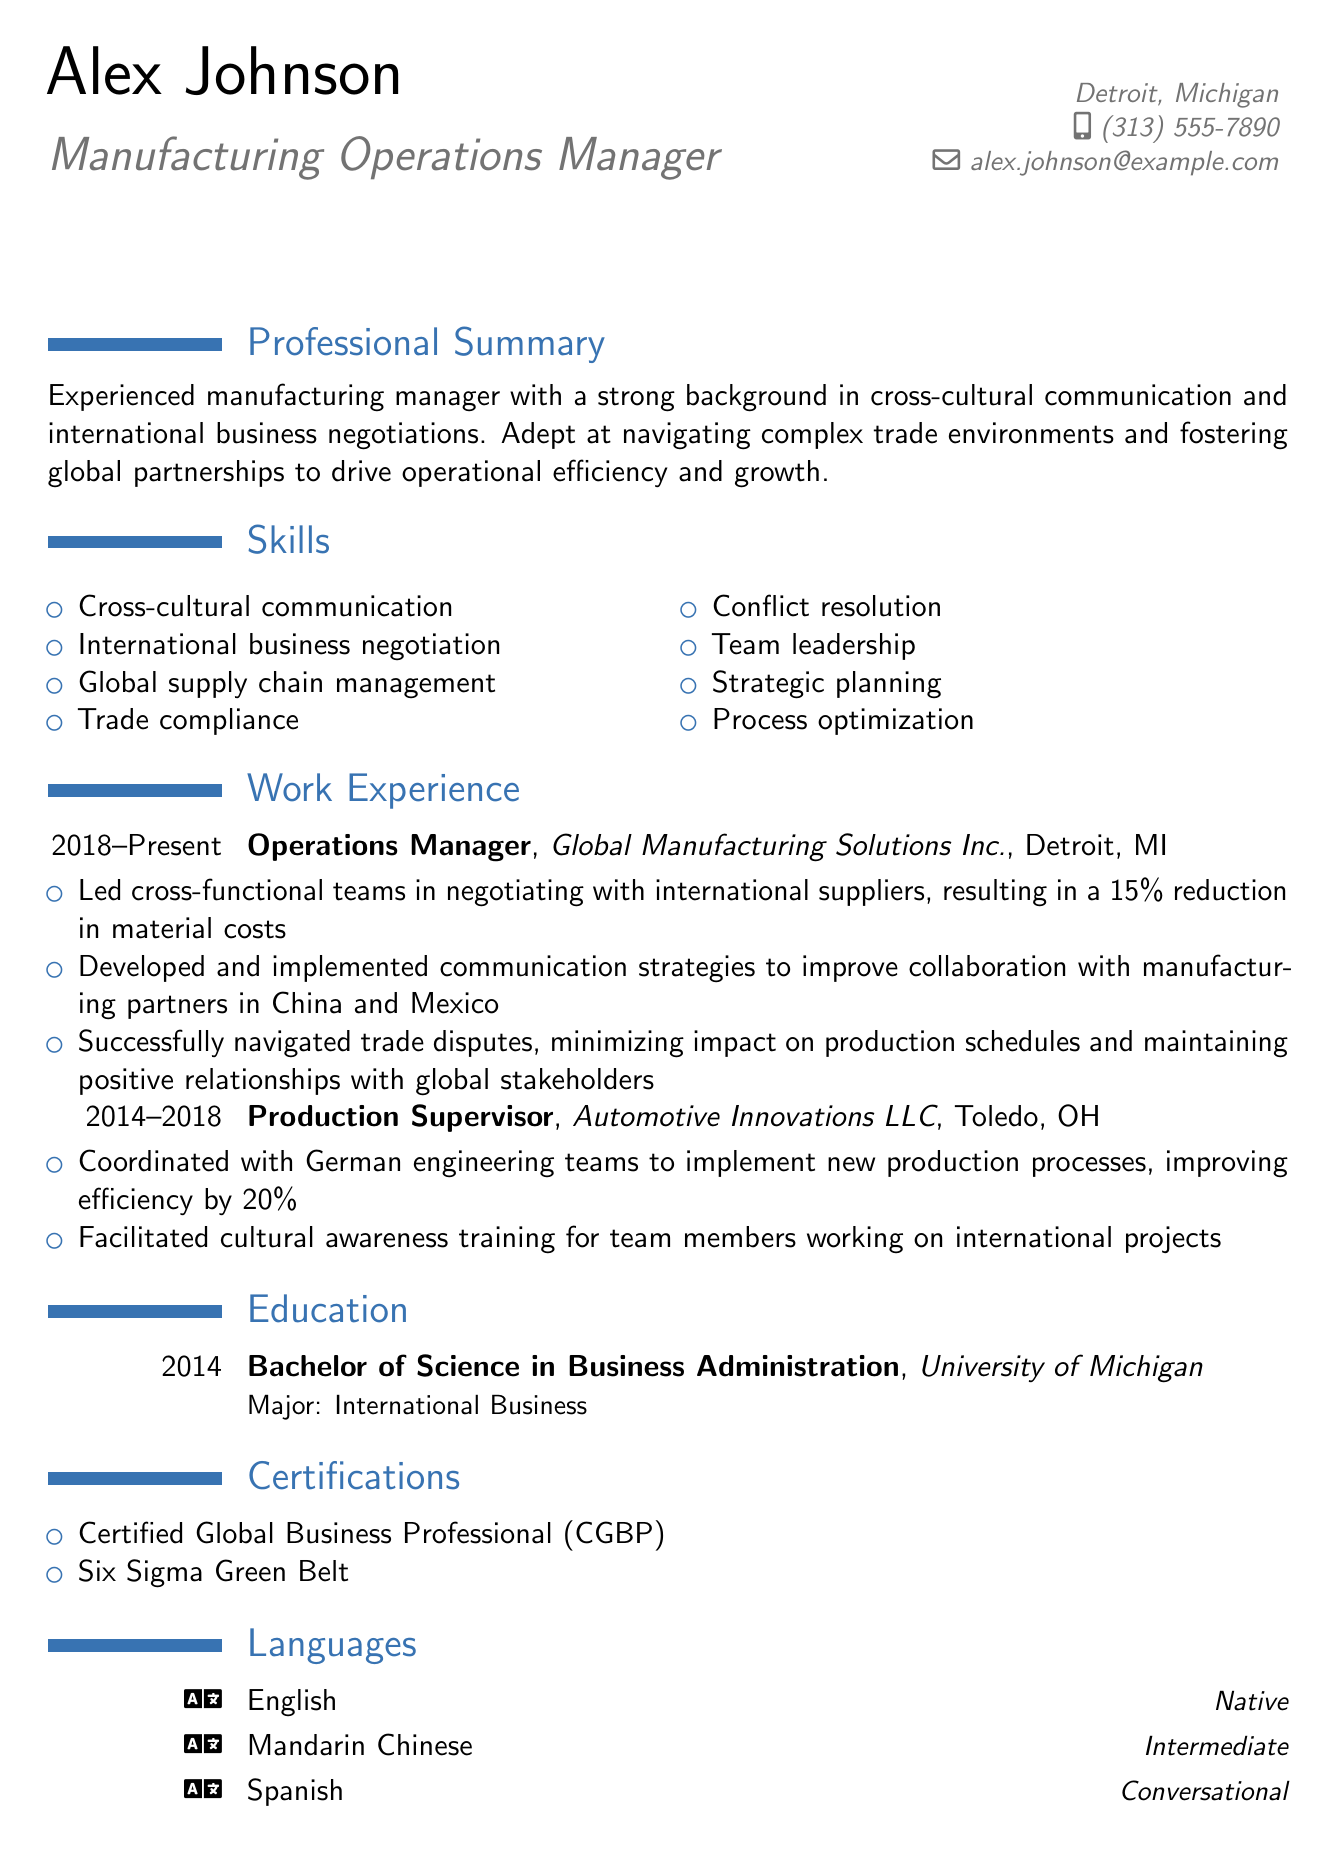What is the name of the individual? The individual's name is listed in the personal information section of the document.
Answer: Alex Johnson What is the degree obtained by Alex Johnson? The education section specifies the degree obtained by Alex Johnson.
Answer: Bachelor of Science in Business Administration Which company does Alex currently work for? The work experience section indicates the name of the current employer.
Answer: Global Manufacturing Solutions Inc What certification does Alex hold related to global business? The certifications section lists specific qualifications.
Answer: Certified Global Business Professional (CGBP) In what city is Alex's current employer located? The work experience section specifies the location of the current employer.
Answer: Detroit, MI How many years of experience does Alex have in his current role? The work experience section indicates the duration of employment in the current position.
Answer: 5 years What language does Alex speak at a conversational level? The languages section provides information on language proficiency.
Answer: Spanish What was the percentage increase in efficiency achieved under Alex's supervision at Automotive Innovations LLC? The work experience section details the specific improvement in efficiency.
Answer: 20% What was one outcome of negotiating with international suppliers? The work experience section highlights results achieved through negotiation.
Answer: 15% reduction in material costs 